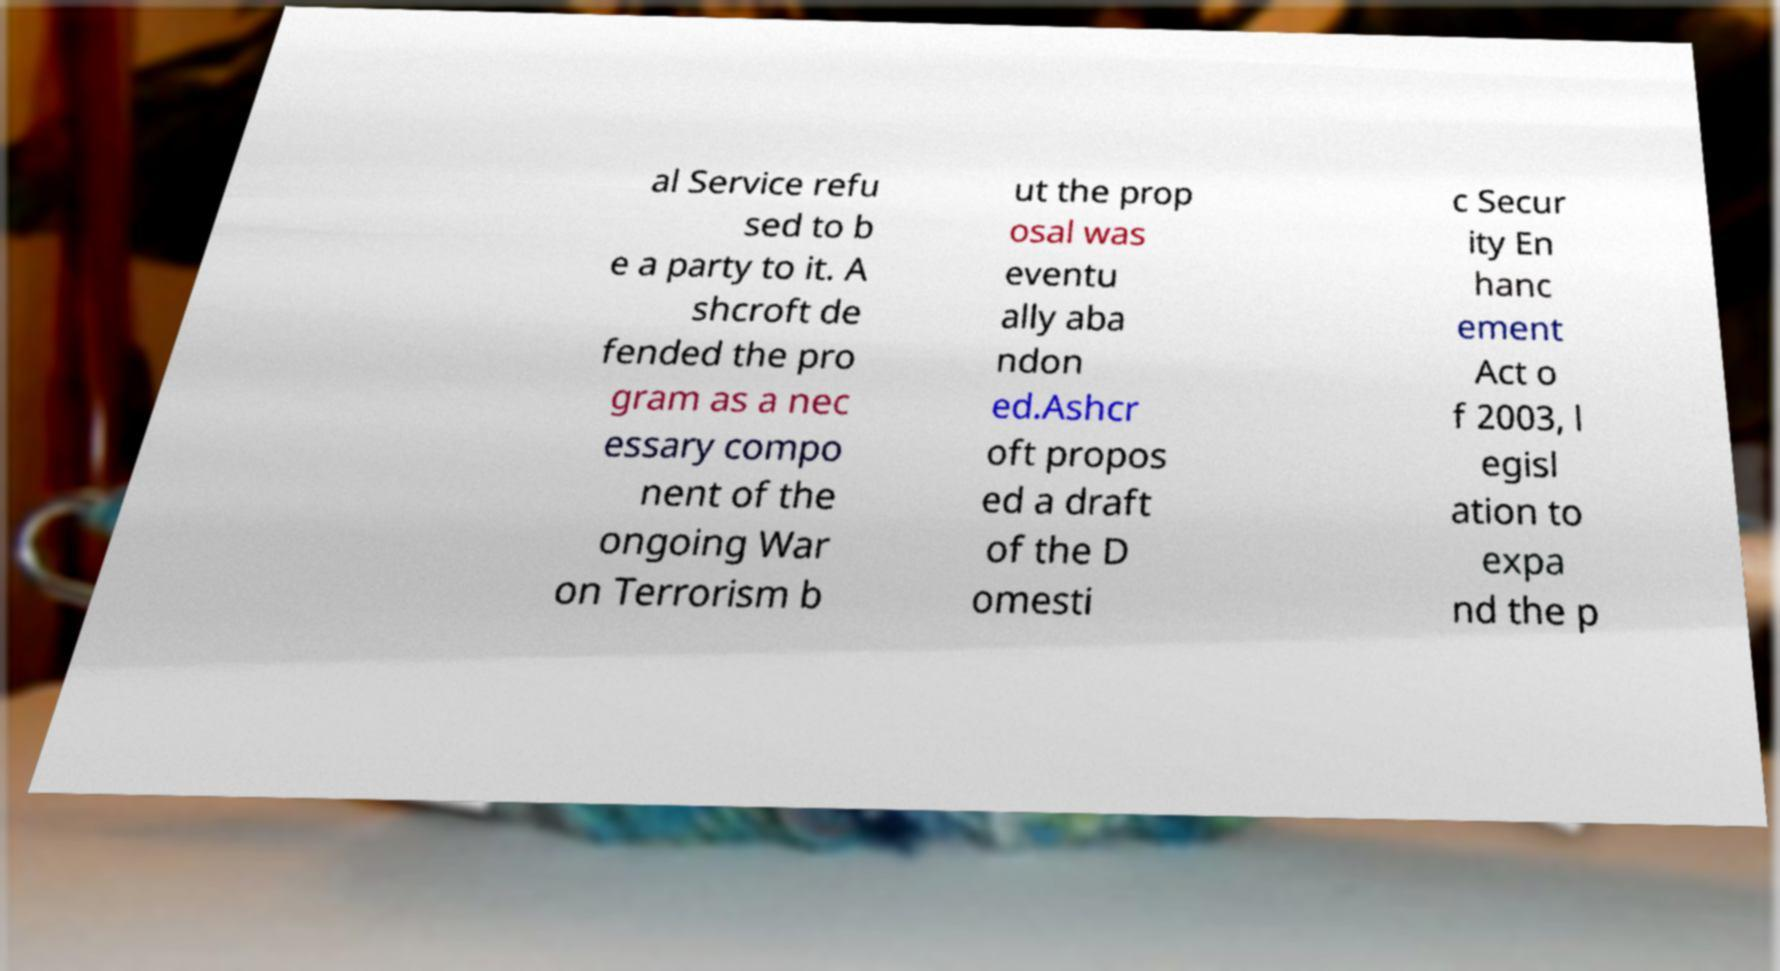Could you assist in decoding the text presented in this image and type it out clearly? al Service refu sed to b e a party to it. A shcroft de fended the pro gram as a nec essary compo nent of the ongoing War on Terrorism b ut the prop osal was eventu ally aba ndon ed.Ashcr oft propos ed a draft of the D omesti c Secur ity En hanc ement Act o f 2003, l egisl ation to expa nd the p 